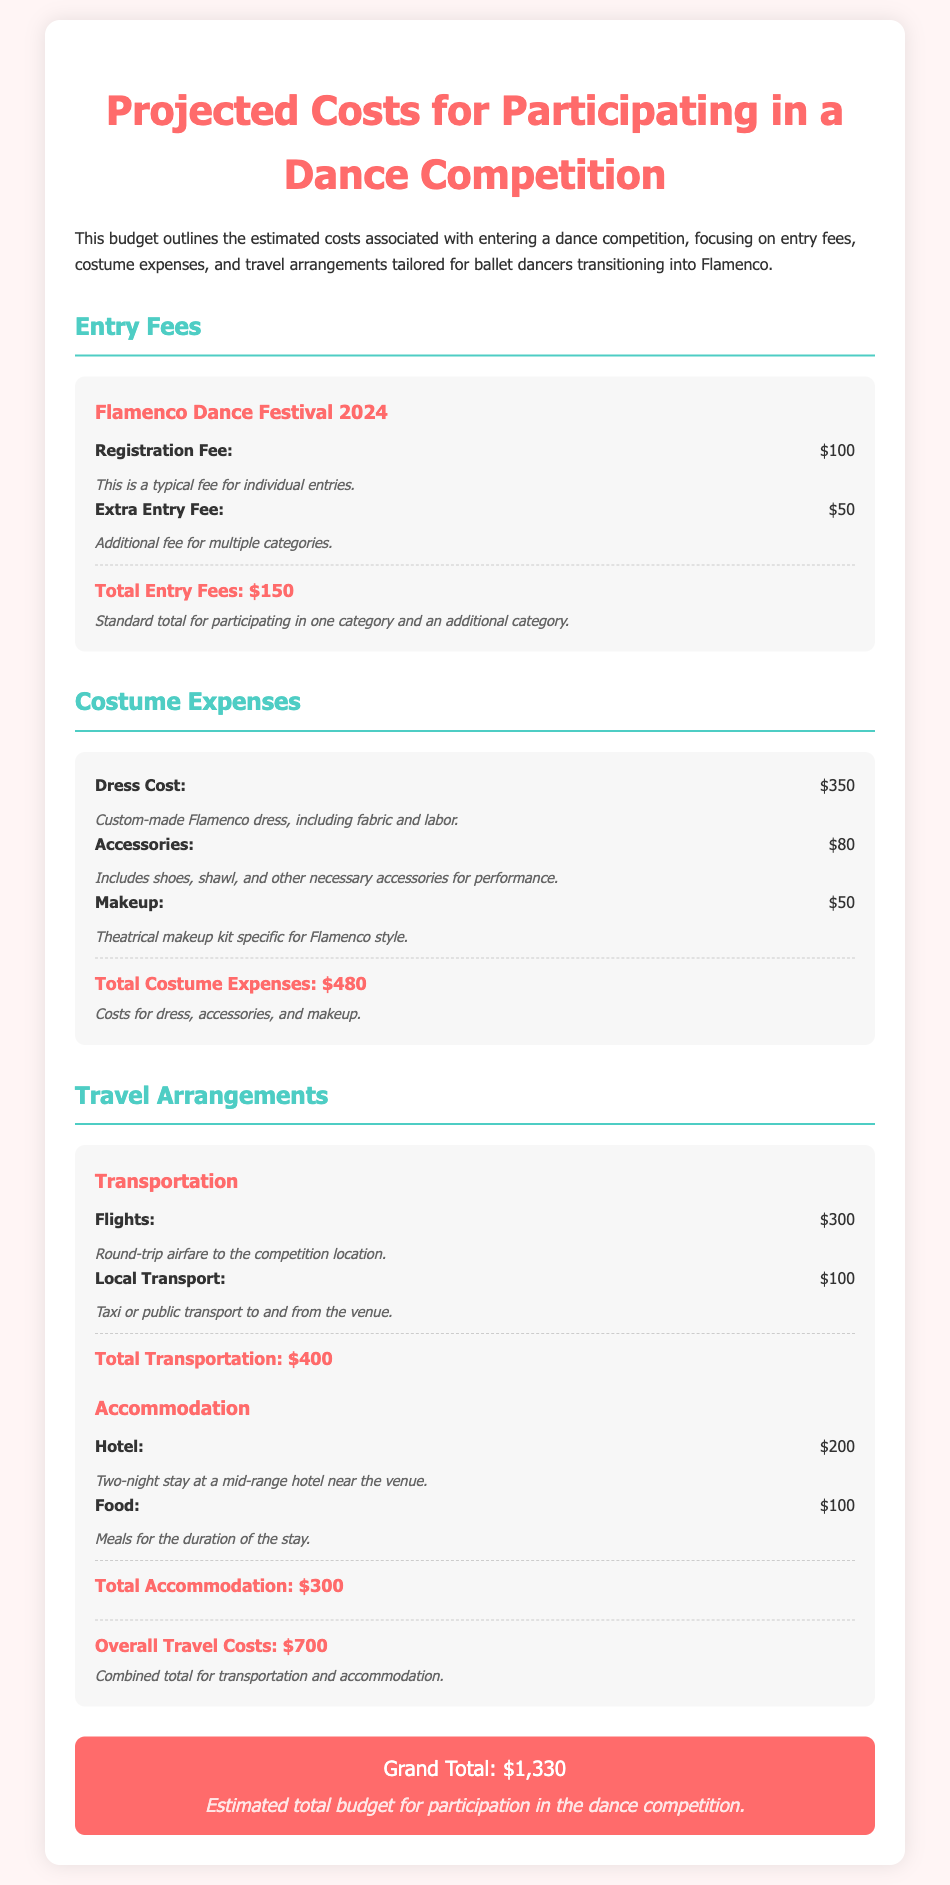What is the total entry fees? The total entry fees are provided as the sum of the registration fee and the extra entry fee, which is $100 + $50 = $150.
Answer: $150 What is the dress cost? The document states that the dress cost for the Flamenco costume is $350.
Answer: $350 How much is the local transport expense? The local transport expense is listed as $100.
Answer: $100 What are the total costume expenses? The total costume expenses are the sum of the dress cost, accessories, and makeup, which equals $350 + $80 + $50 = $480.
Answer: $480 What is the total travel cost? The overall travel costs include both transportation and accommodation, reaching a total of $700.
Answer: $700 How much is the grand total for the budget? The grand total is explicitly mentioned as $1,330 in the document.
Answer: $1,330 What is included in the makeup cost? The makeup cost includes a theatrical makeup kit specific for Flamenco style, priced at $50.
Answer: $50 How many nights is the hotel stay? The hotel stay duration mentioned in the document is for two nights.
Answer: Two nights What documentary notes accompany the registration fee? The notes indicate that this is a typical fee for individual entries.
Answer: Typical fee for individual entries 